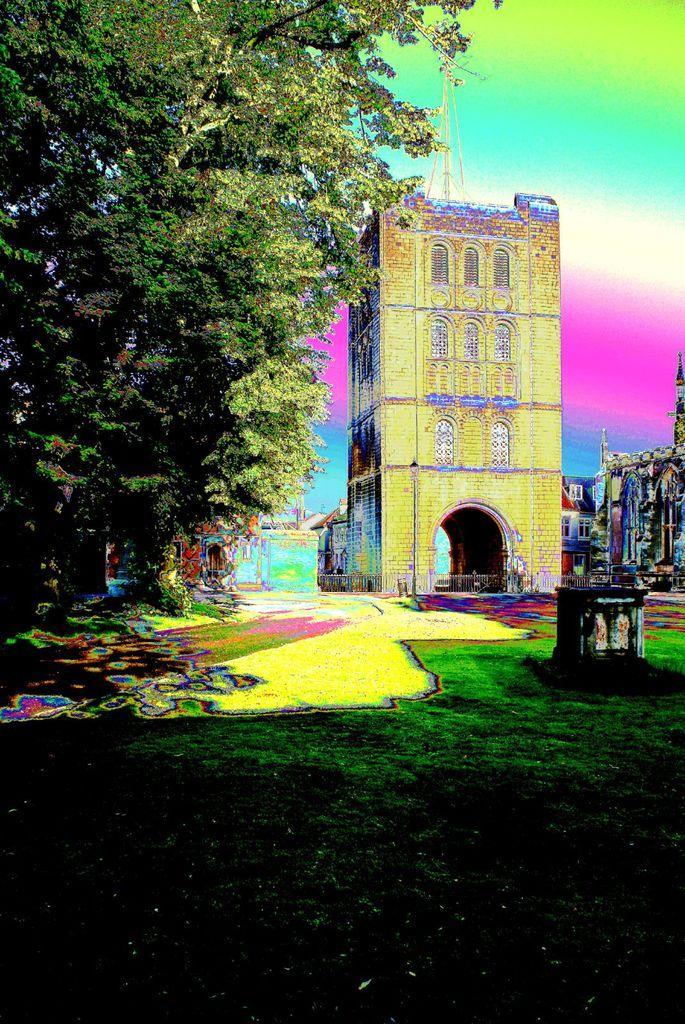Could you give a brief overview of what you see in this image? In this image we can see grass, fence, trees, buildings, tower and the colorful background. 